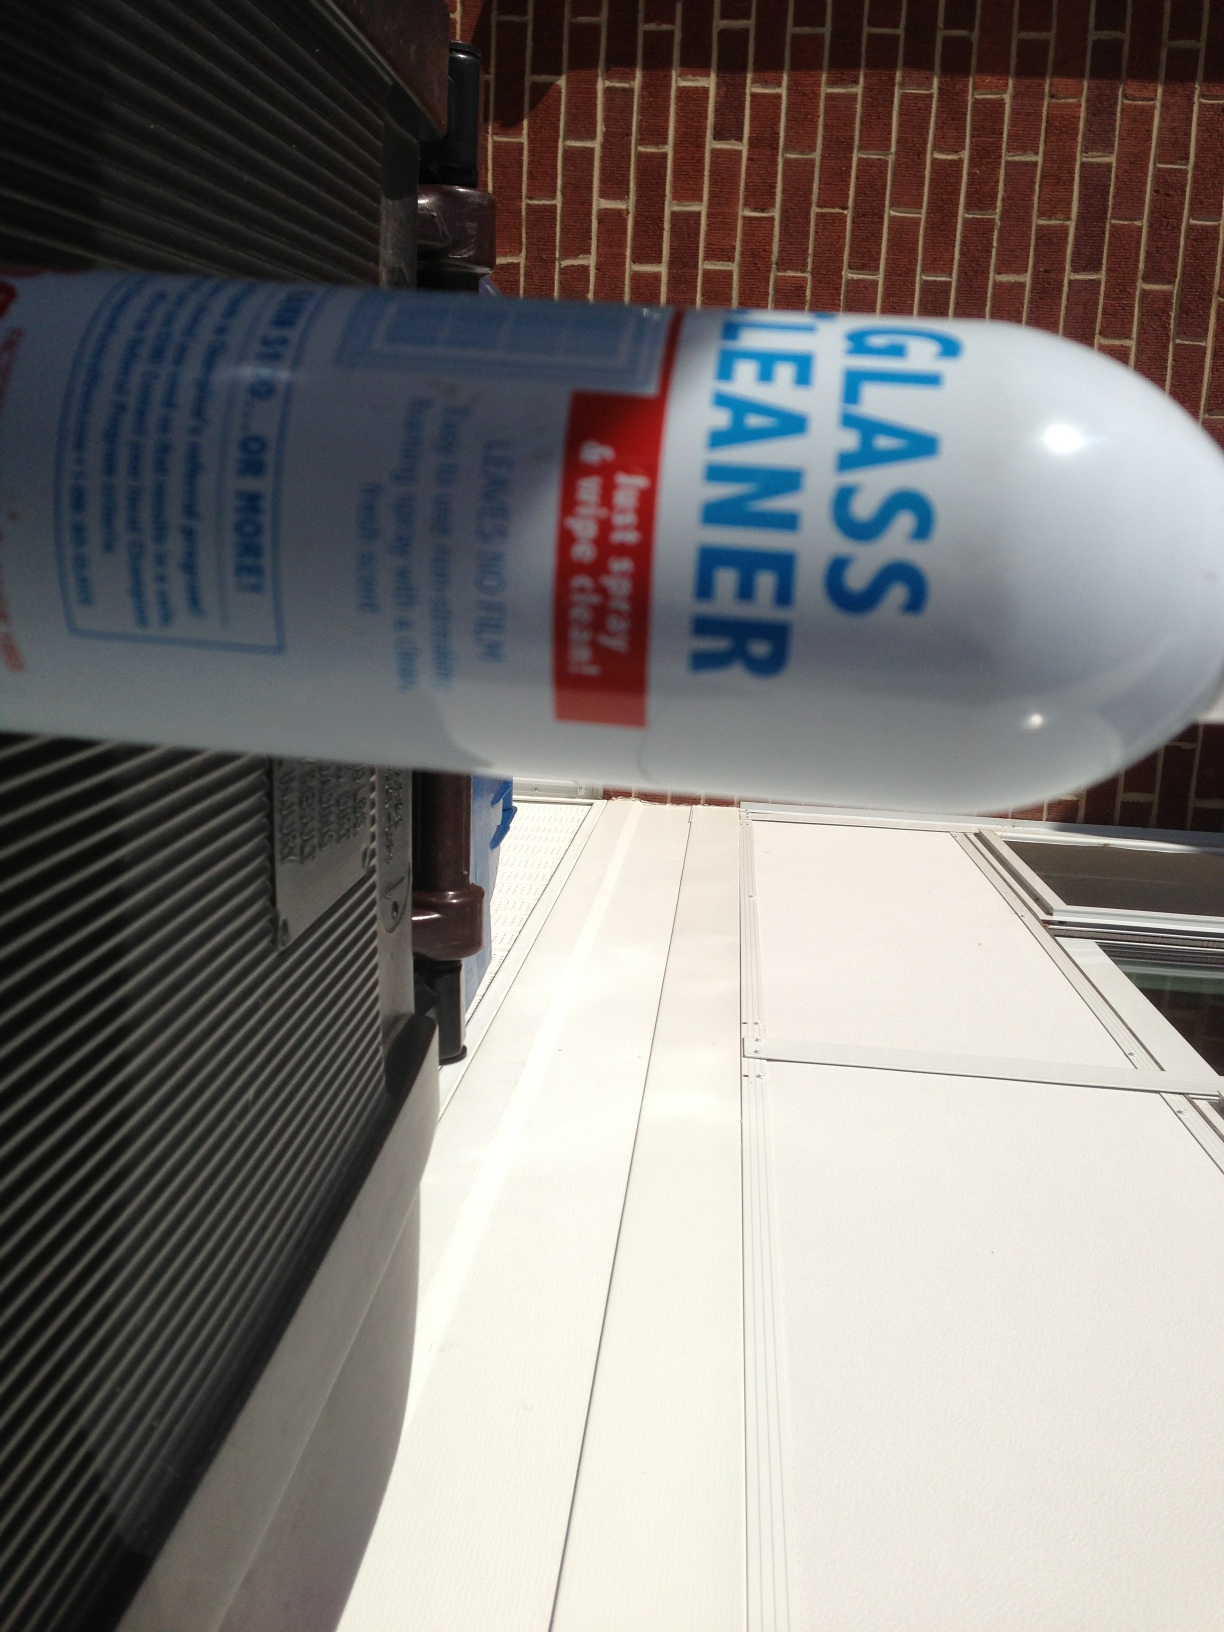Is this product safe for all types of glass? Glass cleaner is generally safe for a variety of glass surfaces. However, it's advisable to check the label for any specific precautions or recommendations regarding different types of glass. Some tinted or treated glass may have special care instructions. Additionally, test the cleaner on a small, inconspicuous area first if you're unsure about compatibility. 